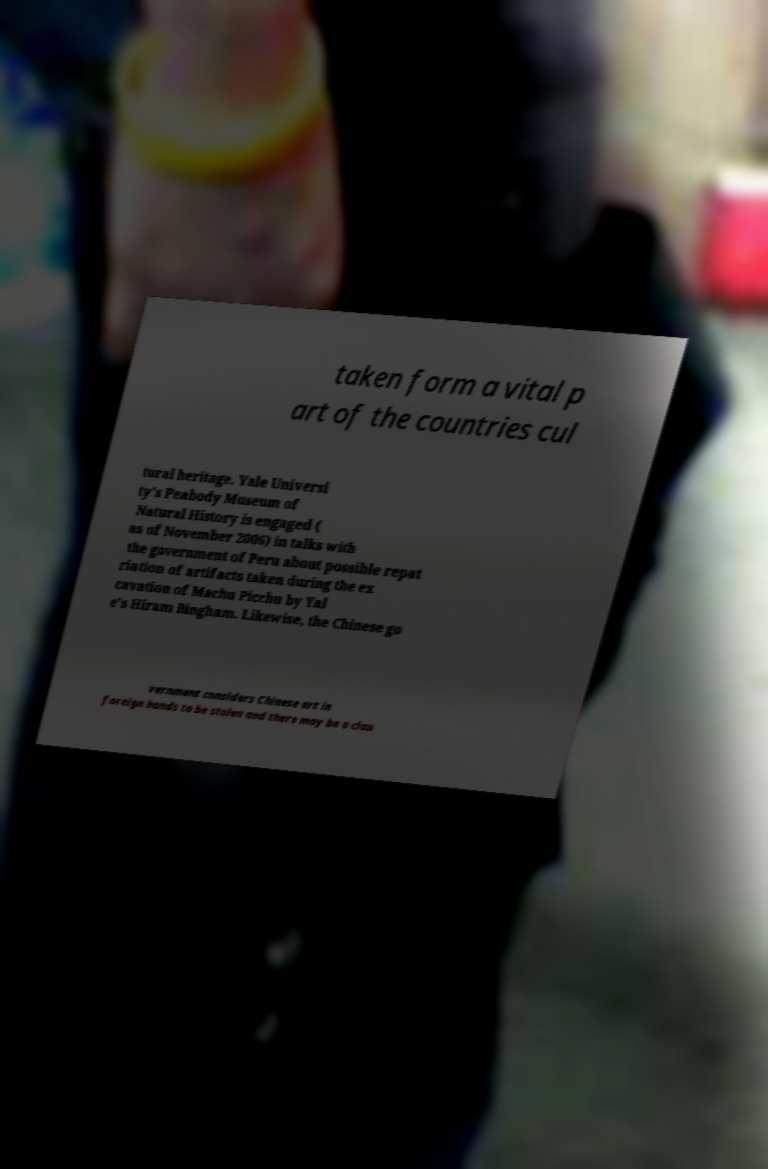Can you accurately transcribe the text from the provided image for me? taken form a vital p art of the countries cul tural heritage. Yale Universi ty's Peabody Museum of Natural History is engaged ( as of November 2006) in talks with the government of Peru about possible repat riation of artifacts taken during the ex cavation of Machu Picchu by Yal e's Hiram Bingham. Likewise, the Chinese go vernment considers Chinese art in foreign hands to be stolen and there may be a clan 